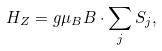Convert formula to latex. <formula><loc_0><loc_0><loc_500><loc_500>H _ { Z } = g \mu _ { B } { B } \cdot \sum _ { j } { S } _ { j } ,</formula> 